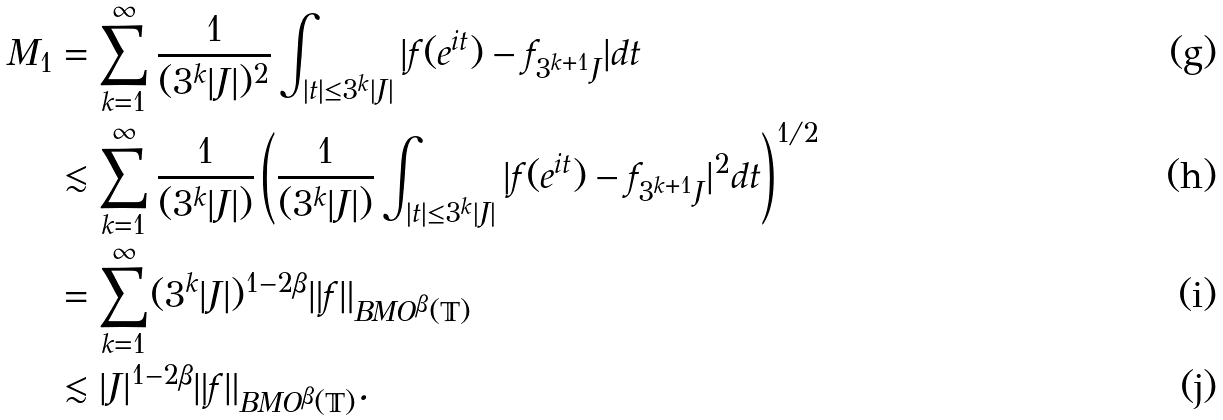<formula> <loc_0><loc_0><loc_500><loc_500>M _ { 1 } & = \sum _ { k = 1 } ^ { \infty } \frac { 1 } { ( 3 ^ { k } | J | ) ^ { 2 } } \int _ { | t | \leq 3 ^ { k } | J | } | f ( e ^ { i t } ) - f _ { 3 ^ { k + 1 } J } | d t \\ & \lesssim \sum _ { k = 1 } ^ { \infty } \frac { 1 } { ( 3 ^ { k } | J | ) } \left ( \frac { 1 } { ( 3 ^ { k } | J | ) } \int _ { | t | \leq 3 ^ { k } | J | } | f ( e ^ { i t } ) - f _ { 3 ^ { k + 1 } J } | ^ { 2 } d t \right ) ^ { 1 / 2 } \\ & = \sum _ { k = 1 } ^ { \infty } ( 3 ^ { k } | J | ) ^ { 1 - 2 \beta } \| f \| _ { B M O ^ { \beta } ( \mathbb { T } ) } \\ & \lesssim | J | ^ { 1 - 2 \beta } \| f \| _ { B M O ^ { \beta } ( \mathbb { T } ) } .</formula> 